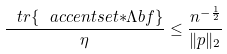<formula> <loc_0><loc_0><loc_500><loc_500>\frac { \ t r \{ \ a c c e n t s e t { \ast } { \Lambda b f } \} } { \eta } \leq \frac { n ^ { - \frac { 1 } { 2 } } } { \| p { \| } _ { 2 } }</formula> 